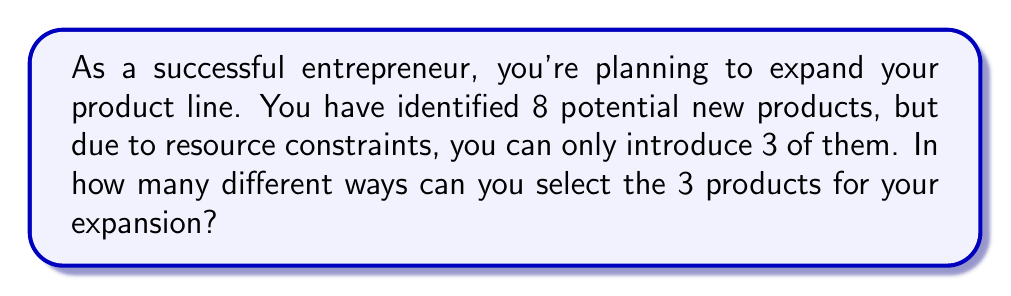Could you help me with this problem? Let's approach this step-by-step:

1) This is a combination problem. We're selecting 3 items from a set of 8, where the order doesn't matter.

2) The formula for combinations is:

   $$C(n,r) = \frac{n!}{r!(n-r)!}$$

   Where $n$ is the total number of items to choose from, and $r$ is the number of items being chosen.

3) In this case, $n = 8$ (total products) and $r = 3$ (products to be selected).

4) Substituting these values into our formula:

   $$C(8,3) = \frac{8!}{3!(8-3)!} = \frac{8!}{3!5!}$$

5) Expand this:
   $$\frac{8 \times 7 \times 6 \times 5!}{(3 \times 2 \times 1) \times 5!}$$

6) The 5! cancels out in the numerator and denominator:
   $$\frac{8 \times 7 \times 6}{3 \times 2 \times 1} = \frac{336}{6}$$

7) Perform the division:
   $$336 \div 6 = 56$$

Therefore, there are 56 different ways to select 3 products out of 8 for your product line expansion.
Answer: 56 